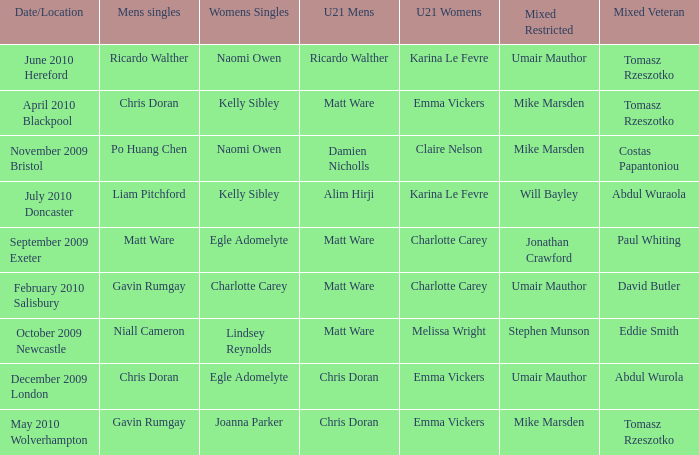When Paul Whiting won the mixed veteran, who won the mixed restricted? Jonathan Crawford. 